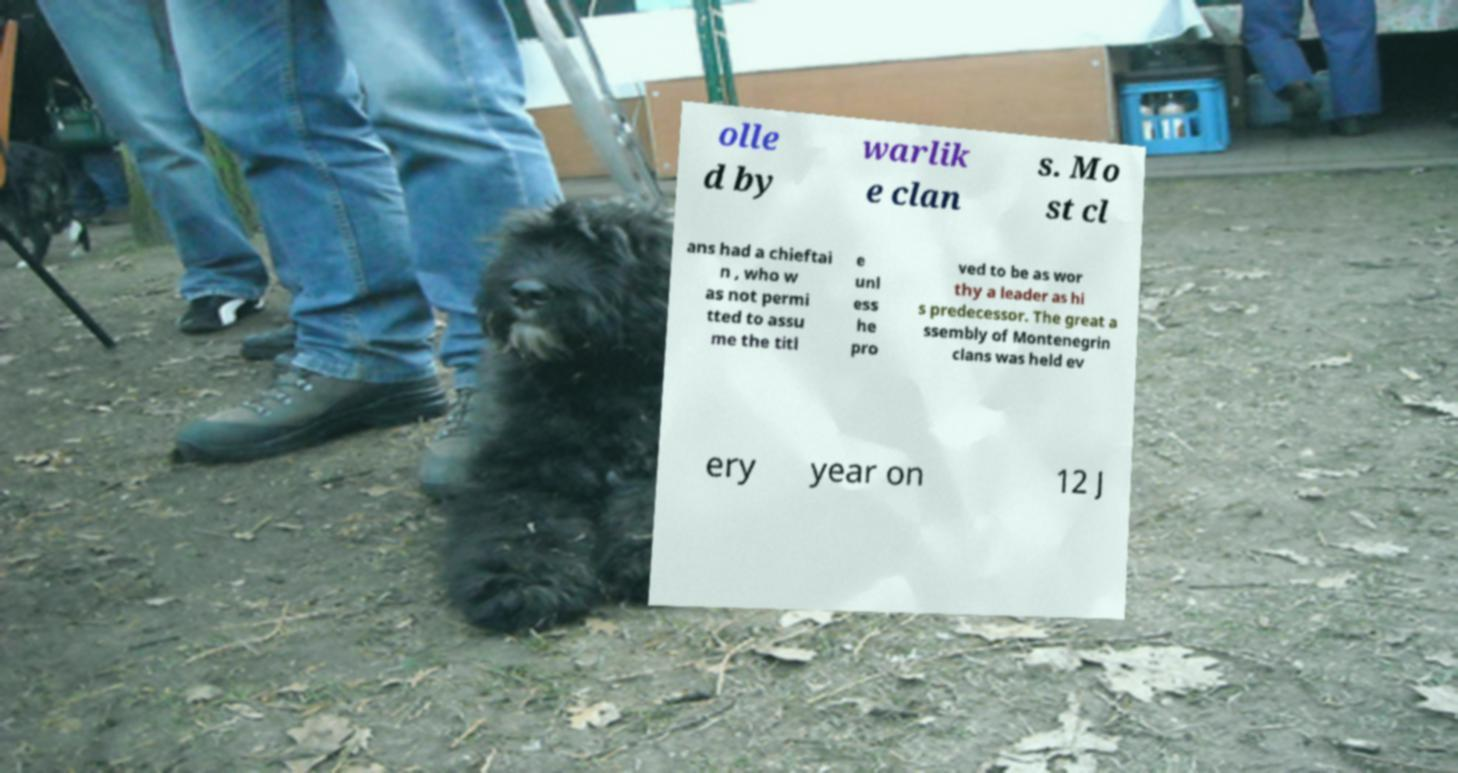Please identify and transcribe the text found in this image. olle d by warlik e clan s. Mo st cl ans had a chieftai n , who w as not permi tted to assu me the titl e unl ess he pro ved to be as wor thy a leader as hi s predecessor. The great a ssembly of Montenegrin clans was held ev ery year on 12 J 